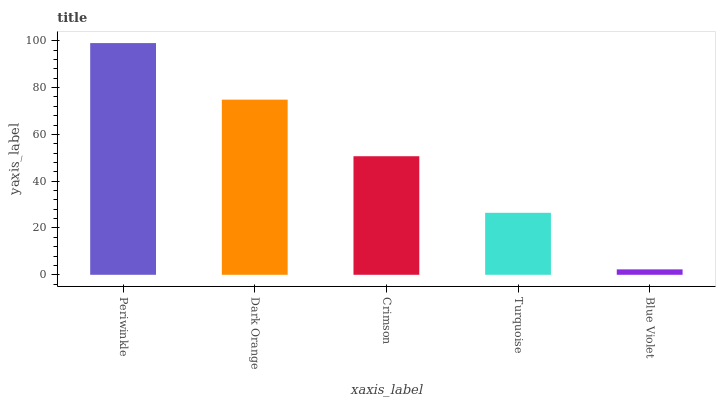Is Dark Orange the minimum?
Answer yes or no. No. Is Dark Orange the maximum?
Answer yes or no. No. Is Periwinkle greater than Dark Orange?
Answer yes or no. Yes. Is Dark Orange less than Periwinkle?
Answer yes or no. Yes. Is Dark Orange greater than Periwinkle?
Answer yes or no. No. Is Periwinkle less than Dark Orange?
Answer yes or no. No. Is Crimson the high median?
Answer yes or no. Yes. Is Crimson the low median?
Answer yes or no. Yes. Is Blue Violet the high median?
Answer yes or no. No. Is Dark Orange the low median?
Answer yes or no. No. 